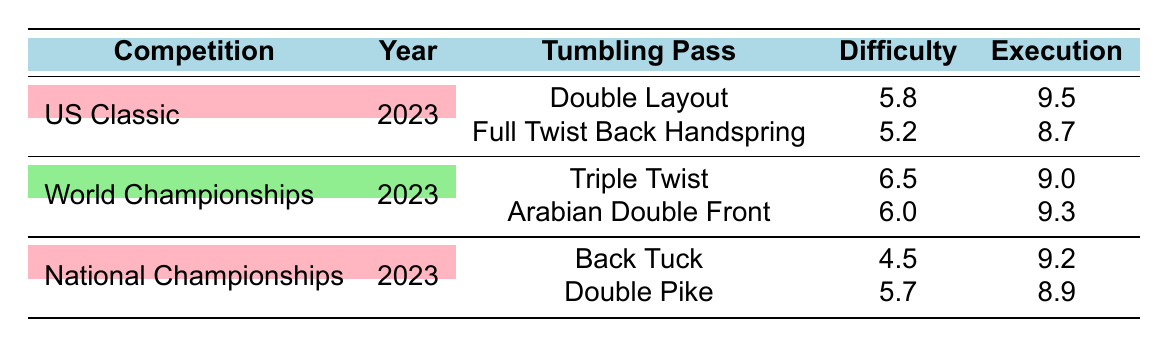What is the highest total score recorded in the US Classic? In the US Classic, the tumbling passes are "Double Layout" with a total score of 15.3 and "Full Twist Back Handspring" with a total score of 13.9. The highest score is 15.3 from the "Double Layout."
Answer: 15.3 What is the difficulty score for the "Triple Twist" pass? The "Triple Twist" pass performed at the World Championships has a difficulty score of 6.5 as listed in the table.
Answer: 6.5 Which tumbling pass received the highest execution score? To find the highest execution score, we compare all the execution scores: 9.5 (Double Layout), 8.7 (Full Twist Back Handspring), 9.0 (Triple Twist), 9.3 (Arabian Double Front), 9.2 (Back Tuck), and 8.9 (Double Pike). The highest score is 9.5 for the "Double Layout."
Answer: 9.5 Is the difficulty score for "Double Pike" higher than the difficulty score for "Back Tuck"? The difficulty score for "Double Pike" is 5.7, while "Back Tuck" has a score of 4.5. Since 5.7 is greater than 4.5, the statement is true.
Answer: Yes What is the average execution score across all tumbling passes? The execution scores are 9.5, 8.7, 9.0, 9.3, 9.2, and 8.9. First, sum these scores: 9.5 + 8.7 + 9.0 + 9.3 + 9.2 + 8.9 = 54.6. There are 6 scores, so the average is 54.6 / 6 = 9.1.
Answer: 9.1 Which competition has the tumbling pass with the lowest total score? The "Back Tuck" under the National Championships has a total score of 13.7, which is the lowest compared to other total scores: 15.3 (US Classic), 15.5 (World Championships), 13.9 (US Classic), and 14.6 (National Championships).
Answer: National Championships What is the total score for the "Arabian Double Front" pass? The "Arabian Double Front" pass has a total score of 15.3 as shown in the World Championships section of the table.
Answer: 15.3 What is the difference between the highest and lowest difficulty scores? The highest difficulty score is 6.5 (Triple Twist) and the lowest is 4.5 (Back Tuck). The difference is calculated as 6.5 - 4.5 = 2.0.
Answer: 2.0 